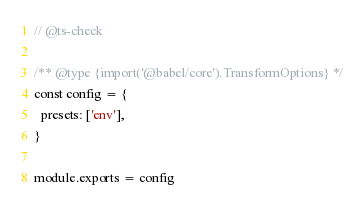Convert code to text. <code><loc_0><loc_0><loc_500><loc_500><_JavaScript_>// @ts-check

/** @type {import('@babel/core').TransformOptions} */
const config = {
  presets: ['env'],
}

module.exports = config
</code> 